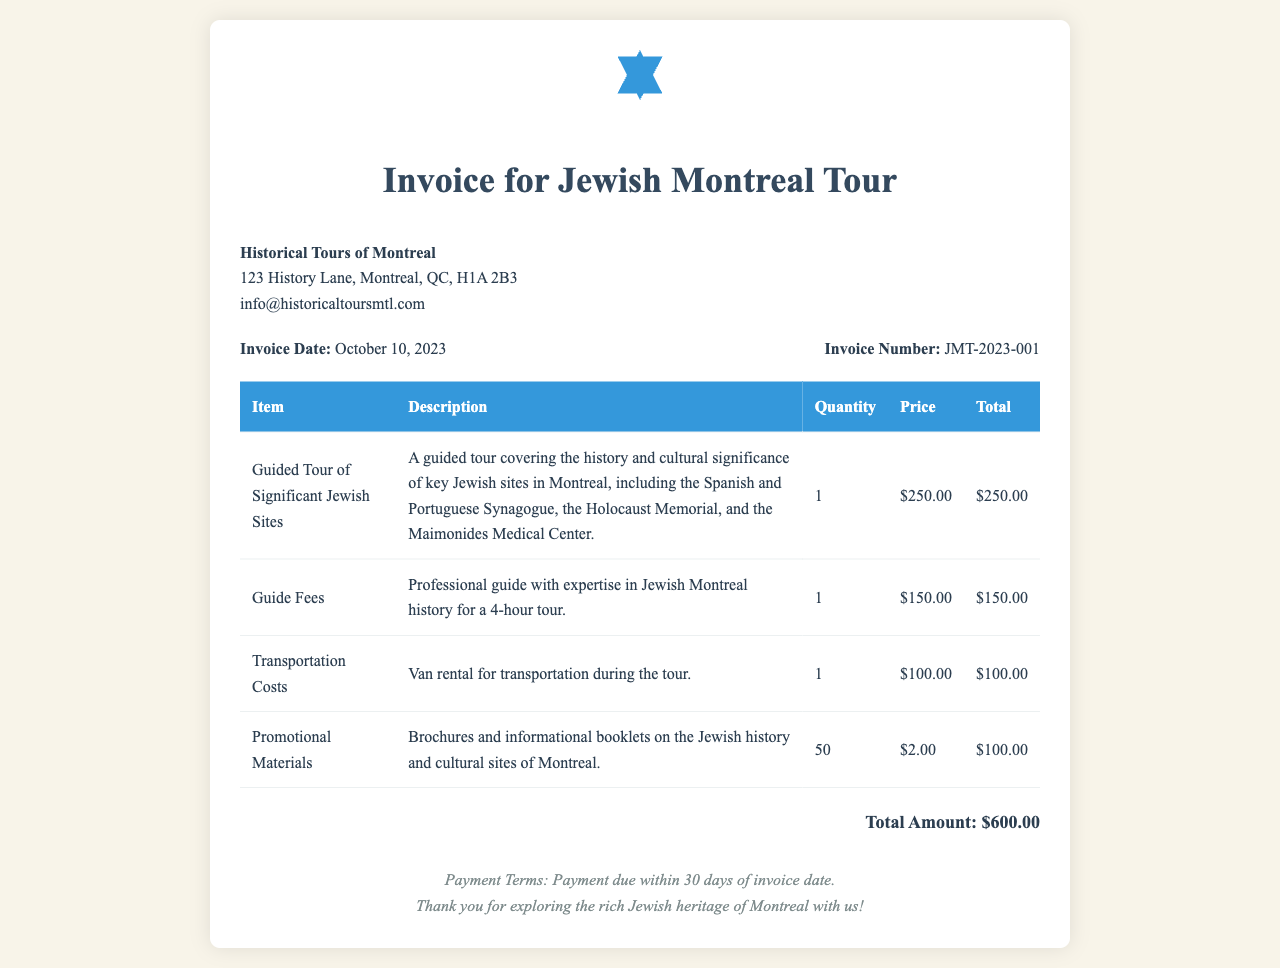What is the total amount? The total amount is calculated from the sum of all item totals in the invoice, which is $250 + $150 + $100 + $100.
Answer: $600.00 What is the invoice number? The invoice number is a unique identifier for this specific document, found near the top.
Answer: JMT-2023-001 How many brochures are provided? The quantity of promotional materials is specified in the table, particularly for brochures and informational booklets.
Answer: 50 What is the price of the guided tour? The price for the guided tour is listed as part of the itemized charges in the invoice.
Answer: $250.00 What are the payment terms? The payment terms detail when payment is due, presented in the footer section of the document.
Answer: Payment due within 30 days of invoice date What date was the invoice issued? The invoice date indicates when this invoice was created and is displayed prominently.
Answer: October 10, 2023 What type of document is this? The document is primarily an invoice related to a specific service offered to customers, evident from the header.
Answer: Invoice for Jewish Montreal Tour What transportation method is mentioned? The document describes transportation costs related to the tour, specifying the method used for travel.
Answer: Van rental 